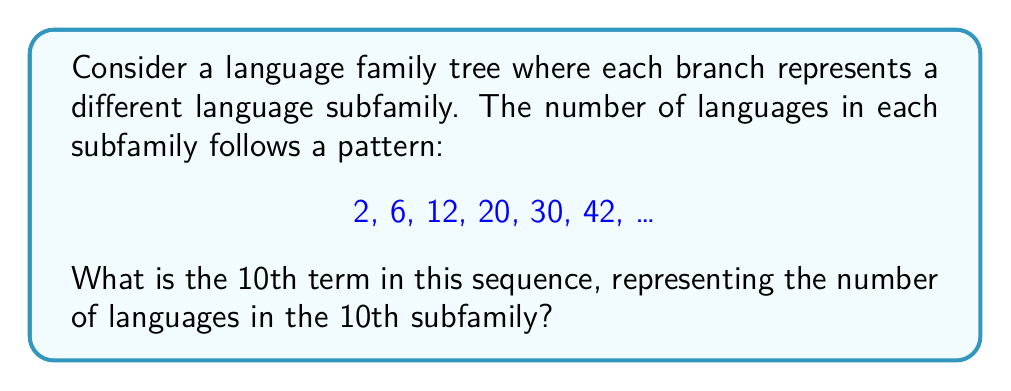Solve this math problem. Let's analyze the pattern step-by-step:

1) First, let's look at the differences between consecutive terms:
   2 to 6: difference of 4
   6 to 12: difference of 6
   12 to 20: difference of 8
   20 to 30: difference of 10
   30 to 42: difference of 12

2) We can see that the differences are increasing by 2 each time: 4, 6, 8, 10, 12, ...

3) This suggests that the nth term of the sequence can be represented as:

   $$a_n = a_{n-1} + 2n$$

   Where $a_n$ is the nth term and $a_{n-1}$ is the previous term.

4) We can also derive a general formula for the nth term:

   $$a_n = n^2 + n$$

5) To verify, let's check the 6th term:
   $$a_6 = 6^2 + 6 = 36 + 6 = 42$$
   This matches our given sequence.

6) Now, to find the 10th term, we simply plug 10 into our formula:

   $$a_{10} = 10^2 + 10 = 100 + 10 = 110$$

Therefore, the 10th subfamily in this language family tree would contain 110 languages.
Answer: 110 